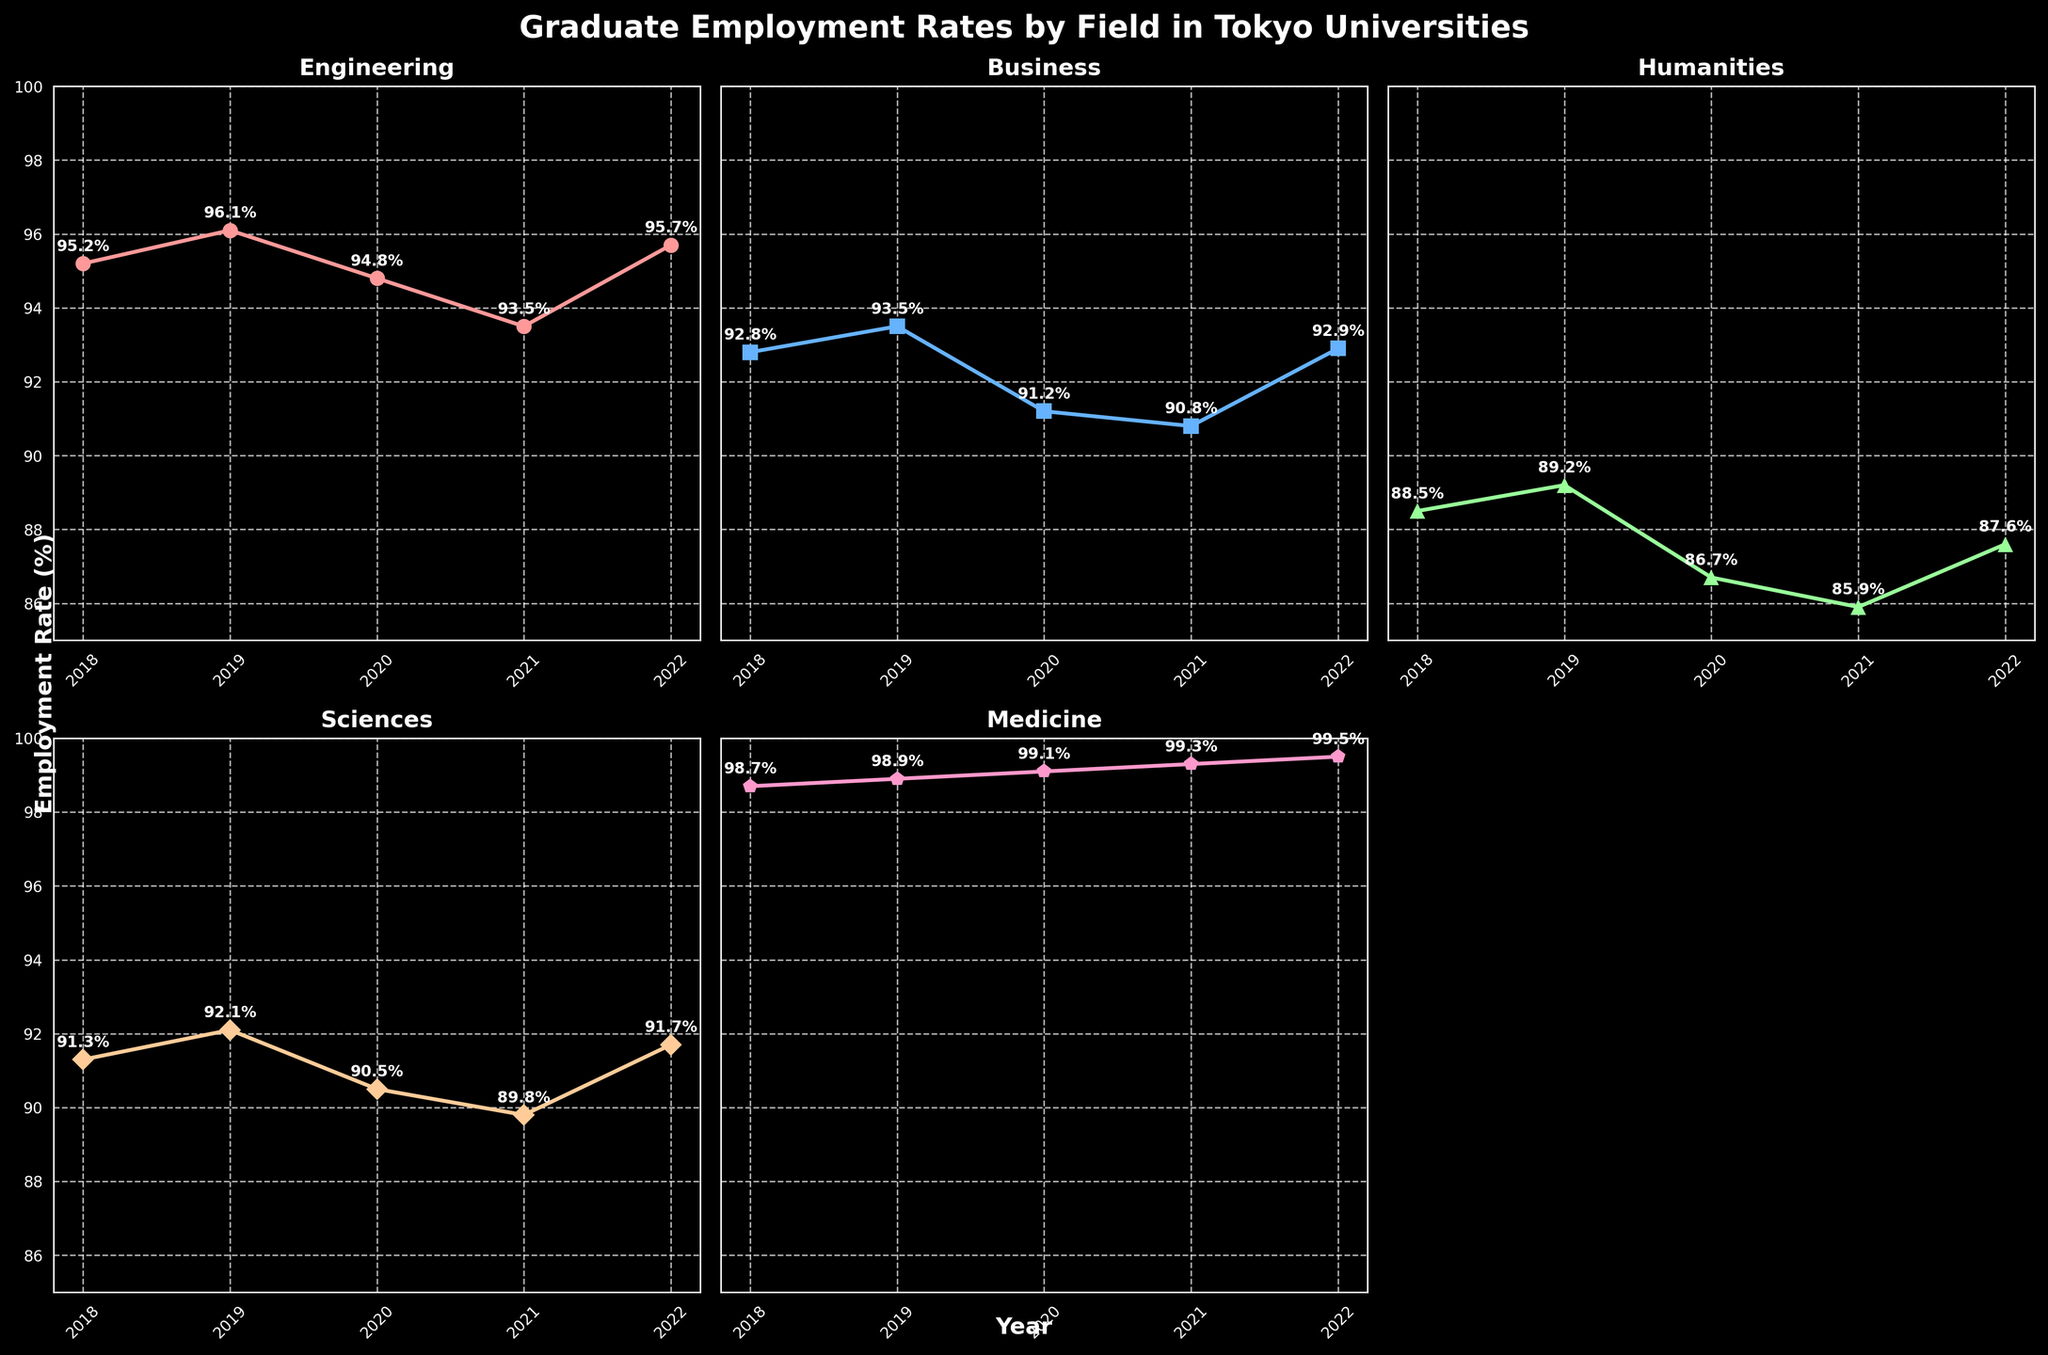what is the title of the figure? The title is placed at the top center of the figure and is usually in a large, bold font. It provides a description of what the figure is about. Here, it is "Graduate Employment Rates by Field in Tokyo Universities."
Answer: Graduate Employment Rates by Field in Tokyo Universities Which academic field had the highest employment rate in 2022? To find the highest employment rate in 2022, look at the data points for all fields in that year. Medicine has the highest employment rate of 99.5%.
Answer: Medicine How does the employment rate of Humanities change from 2018 to 2022? To determine the change, look at the values of Humanities in 2018 and 2022. Subtract the 2018 rate (88.5%) from the 2022 rate (87.6%). The rate decreases by 0.9%.
Answer: It decreases by 0.9% Which field had the greatest fluctuation (range) in employment rates from 2018 to 2022? Calculate the range for each field by subtracting the minimum rate from the maximum rate during these years. Medicine has the smallest range, and Engineering has the largest range (96.1% - 93.5% = 2.6%).
Answer: Engineering What is the average employment rate for Sciences over the 5 years? Add all the employment rates for Sciences from 2018 to 2022 and divide by 5. (91.3 + 92.1 + 90.5 + 89.8 + 91.7) / 5 = 91.08
Answer: 91.08 In which year did the Business field experience the lowest employment rate? Compare the employment rates for Business over the five years. The lowest rate, 90.8%, occurred in 2021.
Answer: 2021 Which field showed a consistent increase in employment rates from 2018 to 2022? Scan each subplot for upward trends across the five years. Medicine consistently increased from 98.7% to 99.5%.
Answer: Medicine Compare the employment rates of Sciences and Humanities in 2020. Which one was higher? Look at the data points for both fields in 2020. Sciences had a rate of 90.5% and Humanities had a rate of 86.7%. Sciences is higher.
Answer: Sciences By how much did the employment rate of Engineering change from 2020 to 2021? Find the values for the years in question. For Engineering, the rate changed from 94.8% in 2020 to 93.5% in 2021, a difference of 1.3%.
Answer: 1.3% Which field had the closest employment rates in 2019 and 2022? Calculate the absolute difference between 2019 and 2022 for each field. Business has rates of 93.5% and 92.9%, respectively, with a difference of 0.6%, which is the closest.
Answer: Business 